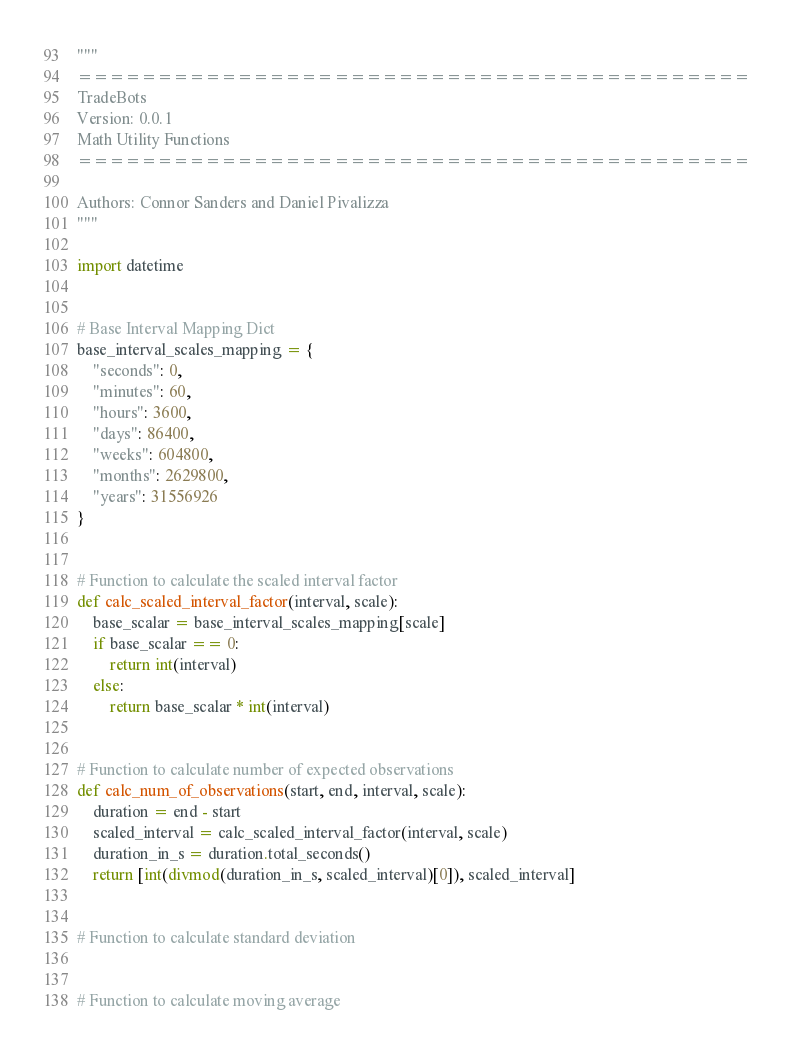Convert code to text. <code><loc_0><loc_0><loc_500><loc_500><_Python_>"""
==========================================
TradeBots
Version: 0.0.1
Math Utility Functions
==========================================

Authors: Connor Sanders and Daniel Pivalizza
"""

import datetime


# Base Interval Mapping Dict
base_interval_scales_mapping = {
    "seconds": 0,
    "minutes": 60,
    "hours": 3600,
    "days": 86400,
    "weeks": 604800,
    "months": 2629800,
    "years": 31556926
}


# Function to calculate the scaled interval factor
def calc_scaled_interval_factor(interval, scale):
    base_scalar = base_interval_scales_mapping[scale]
    if base_scalar == 0:
        return int(interval)
    else:
        return base_scalar * int(interval)


# Function to calculate number of expected observations
def calc_num_of_observations(start, end, interval, scale):
    duration = end - start
    scaled_interval = calc_scaled_interval_factor(interval, scale)
    duration_in_s = duration.total_seconds()
    return [int(divmod(duration_in_s, scaled_interval)[0]), scaled_interval]


# Function to calculate standard deviation


# Function to calculate moving average</code> 